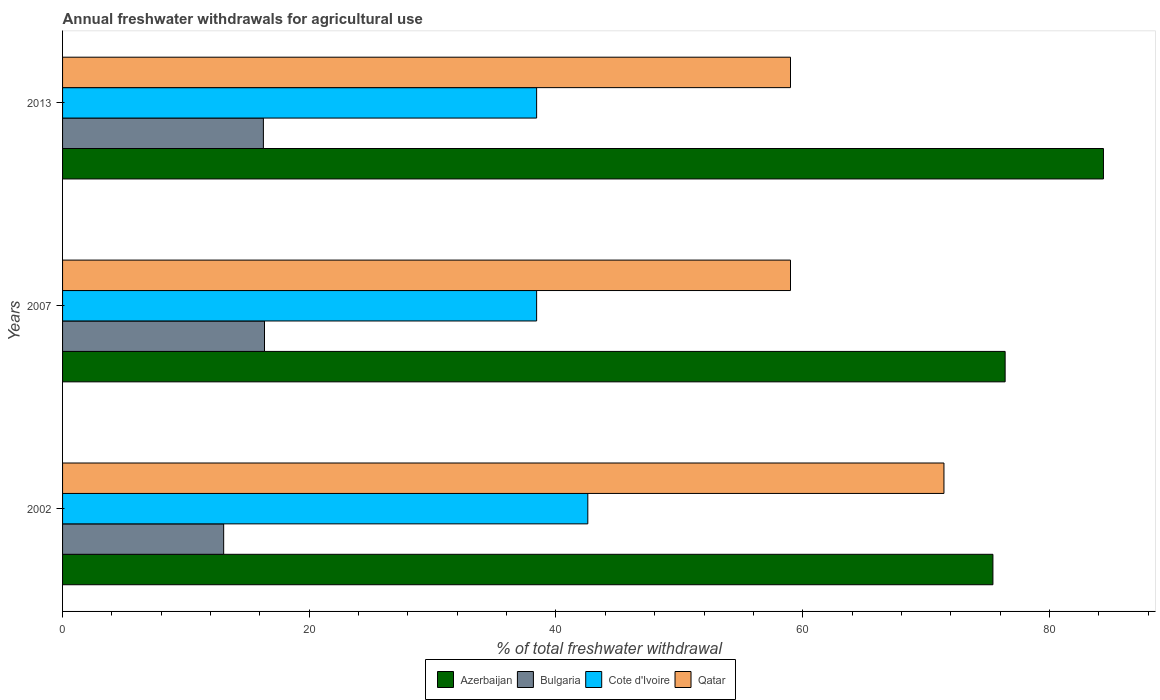How many different coloured bars are there?
Ensure brevity in your answer.  4. How many groups of bars are there?
Give a very brief answer. 3. How many bars are there on the 3rd tick from the top?
Provide a short and direct response. 4. What is the total annual withdrawals from freshwater in Qatar in 2007?
Your answer should be compact. 59.01. Across all years, what is the maximum total annual withdrawals from freshwater in Bulgaria?
Give a very brief answer. 16.37. Across all years, what is the minimum total annual withdrawals from freshwater in Cote d'Ivoire?
Give a very brief answer. 38.43. What is the total total annual withdrawals from freshwater in Cote d'Ivoire in the graph?
Your response must be concise. 119.44. What is the difference between the total annual withdrawals from freshwater in Cote d'Ivoire in 2002 and that in 2013?
Give a very brief answer. 4.15. What is the difference between the total annual withdrawals from freshwater in Azerbaijan in 2013 and the total annual withdrawals from freshwater in Qatar in 2002?
Give a very brief answer. 12.93. What is the average total annual withdrawals from freshwater in Bulgaria per year?
Provide a succinct answer. 15.24. In the year 2002, what is the difference between the total annual withdrawals from freshwater in Cote d'Ivoire and total annual withdrawals from freshwater in Qatar?
Provide a succinct answer. -28.87. What is the ratio of the total annual withdrawals from freshwater in Cote d'Ivoire in 2007 to that in 2013?
Ensure brevity in your answer.  1. Is the difference between the total annual withdrawals from freshwater in Cote d'Ivoire in 2002 and 2013 greater than the difference between the total annual withdrawals from freshwater in Qatar in 2002 and 2013?
Ensure brevity in your answer.  No. What is the difference between the highest and the second highest total annual withdrawals from freshwater in Azerbaijan?
Give a very brief answer. 7.97. What is the difference between the highest and the lowest total annual withdrawals from freshwater in Cote d'Ivoire?
Offer a very short reply. 4.15. Is the sum of the total annual withdrawals from freshwater in Qatar in 2007 and 2013 greater than the maximum total annual withdrawals from freshwater in Cote d'Ivoire across all years?
Provide a succinct answer. Yes. Is it the case that in every year, the sum of the total annual withdrawals from freshwater in Qatar and total annual withdrawals from freshwater in Azerbaijan is greater than the sum of total annual withdrawals from freshwater in Cote d'Ivoire and total annual withdrawals from freshwater in Bulgaria?
Provide a succinct answer. Yes. What does the 2nd bar from the top in 2013 represents?
Ensure brevity in your answer.  Cote d'Ivoire. What does the 2nd bar from the bottom in 2007 represents?
Ensure brevity in your answer.  Bulgaria. How many years are there in the graph?
Your answer should be compact. 3. Does the graph contain grids?
Keep it short and to the point. No. Where does the legend appear in the graph?
Your answer should be very brief. Bottom center. How many legend labels are there?
Provide a succinct answer. 4. What is the title of the graph?
Keep it short and to the point. Annual freshwater withdrawals for agricultural use. Does "Faeroe Islands" appear as one of the legend labels in the graph?
Your answer should be very brief. No. What is the label or title of the X-axis?
Make the answer very short. % of total freshwater withdrawal. What is the label or title of the Y-axis?
Ensure brevity in your answer.  Years. What is the % of total freshwater withdrawal in Azerbaijan in 2002?
Offer a terse response. 75.42. What is the % of total freshwater withdrawal of Bulgaria in 2002?
Give a very brief answer. 13.06. What is the % of total freshwater withdrawal of Cote d'Ivoire in 2002?
Provide a short and direct response. 42.58. What is the % of total freshwater withdrawal of Qatar in 2002?
Provide a succinct answer. 71.45. What is the % of total freshwater withdrawal of Azerbaijan in 2007?
Provide a succinct answer. 76.41. What is the % of total freshwater withdrawal in Bulgaria in 2007?
Your response must be concise. 16.37. What is the % of total freshwater withdrawal of Cote d'Ivoire in 2007?
Keep it short and to the point. 38.43. What is the % of total freshwater withdrawal of Qatar in 2007?
Your response must be concise. 59.01. What is the % of total freshwater withdrawal of Azerbaijan in 2013?
Provide a succinct answer. 84.38. What is the % of total freshwater withdrawal in Bulgaria in 2013?
Offer a very short reply. 16.28. What is the % of total freshwater withdrawal in Cote d'Ivoire in 2013?
Offer a terse response. 38.43. What is the % of total freshwater withdrawal of Qatar in 2013?
Keep it short and to the point. 59.01. Across all years, what is the maximum % of total freshwater withdrawal in Azerbaijan?
Provide a succinct answer. 84.38. Across all years, what is the maximum % of total freshwater withdrawal of Bulgaria?
Ensure brevity in your answer.  16.37. Across all years, what is the maximum % of total freshwater withdrawal of Cote d'Ivoire?
Keep it short and to the point. 42.58. Across all years, what is the maximum % of total freshwater withdrawal of Qatar?
Ensure brevity in your answer.  71.45. Across all years, what is the minimum % of total freshwater withdrawal in Azerbaijan?
Your answer should be compact. 75.42. Across all years, what is the minimum % of total freshwater withdrawal in Bulgaria?
Your response must be concise. 13.06. Across all years, what is the minimum % of total freshwater withdrawal of Cote d'Ivoire?
Your response must be concise. 38.43. Across all years, what is the minimum % of total freshwater withdrawal in Qatar?
Your answer should be compact. 59.01. What is the total % of total freshwater withdrawal of Azerbaijan in the graph?
Your answer should be compact. 236.21. What is the total % of total freshwater withdrawal of Bulgaria in the graph?
Offer a terse response. 45.71. What is the total % of total freshwater withdrawal of Cote d'Ivoire in the graph?
Make the answer very short. 119.44. What is the total % of total freshwater withdrawal in Qatar in the graph?
Provide a short and direct response. 189.47. What is the difference between the % of total freshwater withdrawal in Azerbaijan in 2002 and that in 2007?
Make the answer very short. -0.99. What is the difference between the % of total freshwater withdrawal of Bulgaria in 2002 and that in 2007?
Provide a succinct answer. -3.31. What is the difference between the % of total freshwater withdrawal of Cote d'Ivoire in 2002 and that in 2007?
Provide a succinct answer. 4.15. What is the difference between the % of total freshwater withdrawal of Qatar in 2002 and that in 2007?
Give a very brief answer. 12.44. What is the difference between the % of total freshwater withdrawal in Azerbaijan in 2002 and that in 2013?
Your answer should be very brief. -8.96. What is the difference between the % of total freshwater withdrawal of Bulgaria in 2002 and that in 2013?
Keep it short and to the point. -3.22. What is the difference between the % of total freshwater withdrawal of Cote d'Ivoire in 2002 and that in 2013?
Your response must be concise. 4.15. What is the difference between the % of total freshwater withdrawal of Qatar in 2002 and that in 2013?
Make the answer very short. 12.44. What is the difference between the % of total freshwater withdrawal in Azerbaijan in 2007 and that in 2013?
Provide a succinct answer. -7.97. What is the difference between the % of total freshwater withdrawal of Bulgaria in 2007 and that in 2013?
Provide a short and direct response. 0.09. What is the difference between the % of total freshwater withdrawal of Cote d'Ivoire in 2007 and that in 2013?
Ensure brevity in your answer.  0. What is the difference between the % of total freshwater withdrawal of Azerbaijan in 2002 and the % of total freshwater withdrawal of Bulgaria in 2007?
Ensure brevity in your answer.  59.05. What is the difference between the % of total freshwater withdrawal in Azerbaijan in 2002 and the % of total freshwater withdrawal in Cote d'Ivoire in 2007?
Keep it short and to the point. 36.99. What is the difference between the % of total freshwater withdrawal of Azerbaijan in 2002 and the % of total freshwater withdrawal of Qatar in 2007?
Ensure brevity in your answer.  16.41. What is the difference between the % of total freshwater withdrawal in Bulgaria in 2002 and the % of total freshwater withdrawal in Cote d'Ivoire in 2007?
Make the answer very short. -25.37. What is the difference between the % of total freshwater withdrawal of Bulgaria in 2002 and the % of total freshwater withdrawal of Qatar in 2007?
Make the answer very short. -45.95. What is the difference between the % of total freshwater withdrawal in Cote d'Ivoire in 2002 and the % of total freshwater withdrawal in Qatar in 2007?
Your answer should be very brief. -16.43. What is the difference between the % of total freshwater withdrawal in Azerbaijan in 2002 and the % of total freshwater withdrawal in Bulgaria in 2013?
Ensure brevity in your answer.  59.14. What is the difference between the % of total freshwater withdrawal in Azerbaijan in 2002 and the % of total freshwater withdrawal in Cote d'Ivoire in 2013?
Your answer should be compact. 36.99. What is the difference between the % of total freshwater withdrawal of Azerbaijan in 2002 and the % of total freshwater withdrawal of Qatar in 2013?
Your answer should be compact. 16.41. What is the difference between the % of total freshwater withdrawal of Bulgaria in 2002 and the % of total freshwater withdrawal of Cote d'Ivoire in 2013?
Your answer should be very brief. -25.37. What is the difference between the % of total freshwater withdrawal in Bulgaria in 2002 and the % of total freshwater withdrawal in Qatar in 2013?
Your response must be concise. -45.95. What is the difference between the % of total freshwater withdrawal of Cote d'Ivoire in 2002 and the % of total freshwater withdrawal of Qatar in 2013?
Keep it short and to the point. -16.43. What is the difference between the % of total freshwater withdrawal in Azerbaijan in 2007 and the % of total freshwater withdrawal in Bulgaria in 2013?
Your response must be concise. 60.13. What is the difference between the % of total freshwater withdrawal of Azerbaijan in 2007 and the % of total freshwater withdrawal of Cote d'Ivoire in 2013?
Provide a succinct answer. 37.98. What is the difference between the % of total freshwater withdrawal in Azerbaijan in 2007 and the % of total freshwater withdrawal in Qatar in 2013?
Offer a very short reply. 17.4. What is the difference between the % of total freshwater withdrawal of Bulgaria in 2007 and the % of total freshwater withdrawal of Cote d'Ivoire in 2013?
Offer a very short reply. -22.06. What is the difference between the % of total freshwater withdrawal of Bulgaria in 2007 and the % of total freshwater withdrawal of Qatar in 2013?
Provide a succinct answer. -42.64. What is the difference between the % of total freshwater withdrawal in Cote d'Ivoire in 2007 and the % of total freshwater withdrawal in Qatar in 2013?
Provide a succinct answer. -20.58. What is the average % of total freshwater withdrawal in Azerbaijan per year?
Give a very brief answer. 78.74. What is the average % of total freshwater withdrawal of Bulgaria per year?
Your answer should be compact. 15.24. What is the average % of total freshwater withdrawal of Cote d'Ivoire per year?
Give a very brief answer. 39.81. What is the average % of total freshwater withdrawal in Qatar per year?
Provide a short and direct response. 63.16. In the year 2002, what is the difference between the % of total freshwater withdrawal of Azerbaijan and % of total freshwater withdrawal of Bulgaria?
Ensure brevity in your answer.  62.36. In the year 2002, what is the difference between the % of total freshwater withdrawal of Azerbaijan and % of total freshwater withdrawal of Cote d'Ivoire?
Your answer should be compact. 32.84. In the year 2002, what is the difference between the % of total freshwater withdrawal of Azerbaijan and % of total freshwater withdrawal of Qatar?
Your answer should be very brief. 3.97. In the year 2002, what is the difference between the % of total freshwater withdrawal of Bulgaria and % of total freshwater withdrawal of Cote d'Ivoire?
Ensure brevity in your answer.  -29.52. In the year 2002, what is the difference between the % of total freshwater withdrawal of Bulgaria and % of total freshwater withdrawal of Qatar?
Offer a terse response. -58.39. In the year 2002, what is the difference between the % of total freshwater withdrawal in Cote d'Ivoire and % of total freshwater withdrawal in Qatar?
Your answer should be very brief. -28.87. In the year 2007, what is the difference between the % of total freshwater withdrawal of Azerbaijan and % of total freshwater withdrawal of Bulgaria?
Keep it short and to the point. 60.04. In the year 2007, what is the difference between the % of total freshwater withdrawal of Azerbaijan and % of total freshwater withdrawal of Cote d'Ivoire?
Make the answer very short. 37.98. In the year 2007, what is the difference between the % of total freshwater withdrawal in Bulgaria and % of total freshwater withdrawal in Cote d'Ivoire?
Provide a succinct answer. -22.06. In the year 2007, what is the difference between the % of total freshwater withdrawal of Bulgaria and % of total freshwater withdrawal of Qatar?
Make the answer very short. -42.64. In the year 2007, what is the difference between the % of total freshwater withdrawal of Cote d'Ivoire and % of total freshwater withdrawal of Qatar?
Your answer should be compact. -20.58. In the year 2013, what is the difference between the % of total freshwater withdrawal in Azerbaijan and % of total freshwater withdrawal in Bulgaria?
Give a very brief answer. 68.1. In the year 2013, what is the difference between the % of total freshwater withdrawal in Azerbaijan and % of total freshwater withdrawal in Cote d'Ivoire?
Make the answer very short. 45.95. In the year 2013, what is the difference between the % of total freshwater withdrawal in Azerbaijan and % of total freshwater withdrawal in Qatar?
Make the answer very short. 25.37. In the year 2013, what is the difference between the % of total freshwater withdrawal in Bulgaria and % of total freshwater withdrawal in Cote d'Ivoire?
Ensure brevity in your answer.  -22.15. In the year 2013, what is the difference between the % of total freshwater withdrawal of Bulgaria and % of total freshwater withdrawal of Qatar?
Your answer should be very brief. -42.73. In the year 2013, what is the difference between the % of total freshwater withdrawal of Cote d'Ivoire and % of total freshwater withdrawal of Qatar?
Provide a succinct answer. -20.58. What is the ratio of the % of total freshwater withdrawal of Azerbaijan in 2002 to that in 2007?
Offer a terse response. 0.99. What is the ratio of the % of total freshwater withdrawal in Bulgaria in 2002 to that in 2007?
Give a very brief answer. 0.8. What is the ratio of the % of total freshwater withdrawal in Cote d'Ivoire in 2002 to that in 2007?
Provide a succinct answer. 1.11. What is the ratio of the % of total freshwater withdrawal in Qatar in 2002 to that in 2007?
Your answer should be very brief. 1.21. What is the ratio of the % of total freshwater withdrawal in Azerbaijan in 2002 to that in 2013?
Offer a very short reply. 0.89. What is the ratio of the % of total freshwater withdrawal in Bulgaria in 2002 to that in 2013?
Keep it short and to the point. 0.8. What is the ratio of the % of total freshwater withdrawal in Cote d'Ivoire in 2002 to that in 2013?
Keep it short and to the point. 1.11. What is the ratio of the % of total freshwater withdrawal in Qatar in 2002 to that in 2013?
Your response must be concise. 1.21. What is the ratio of the % of total freshwater withdrawal in Azerbaijan in 2007 to that in 2013?
Keep it short and to the point. 0.91. What is the ratio of the % of total freshwater withdrawal in Cote d'Ivoire in 2007 to that in 2013?
Your answer should be compact. 1. What is the difference between the highest and the second highest % of total freshwater withdrawal of Azerbaijan?
Provide a succinct answer. 7.97. What is the difference between the highest and the second highest % of total freshwater withdrawal of Bulgaria?
Provide a short and direct response. 0.09. What is the difference between the highest and the second highest % of total freshwater withdrawal in Cote d'Ivoire?
Make the answer very short. 4.15. What is the difference between the highest and the second highest % of total freshwater withdrawal of Qatar?
Provide a succinct answer. 12.44. What is the difference between the highest and the lowest % of total freshwater withdrawal in Azerbaijan?
Provide a succinct answer. 8.96. What is the difference between the highest and the lowest % of total freshwater withdrawal of Bulgaria?
Ensure brevity in your answer.  3.31. What is the difference between the highest and the lowest % of total freshwater withdrawal in Cote d'Ivoire?
Offer a very short reply. 4.15. What is the difference between the highest and the lowest % of total freshwater withdrawal of Qatar?
Your answer should be compact. 12.44. 